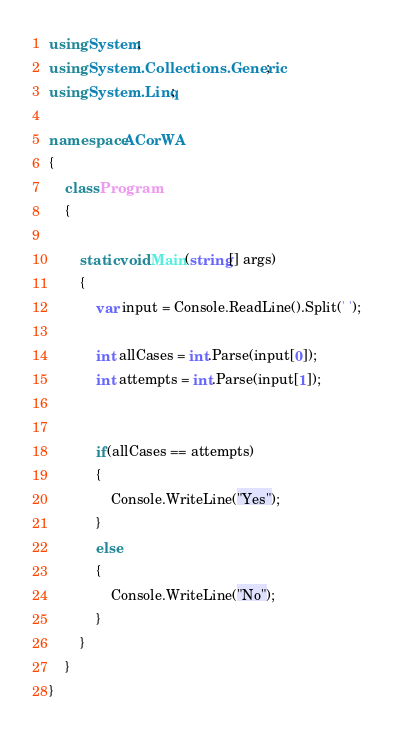<code> <loc_0><loc_0><loc_500><loc_500><_C#_>using System;
using System.Collections.Generic;
using System.Linq;

namespace ACorWA
{
    class Program
    {

        static void Main(string[] args)
        {
            var input = Console.ReadLine().Split(' ');

            int allCases = int.Parse(input[0]);
            int attempts = int.Parse(input[1]);
            

            if(allCases == attempts)
            {
                Console.WriteLine("Yes");
            }
            else
            {
                Console.WriteLine("No");
            }
        }
    }
}</code> 